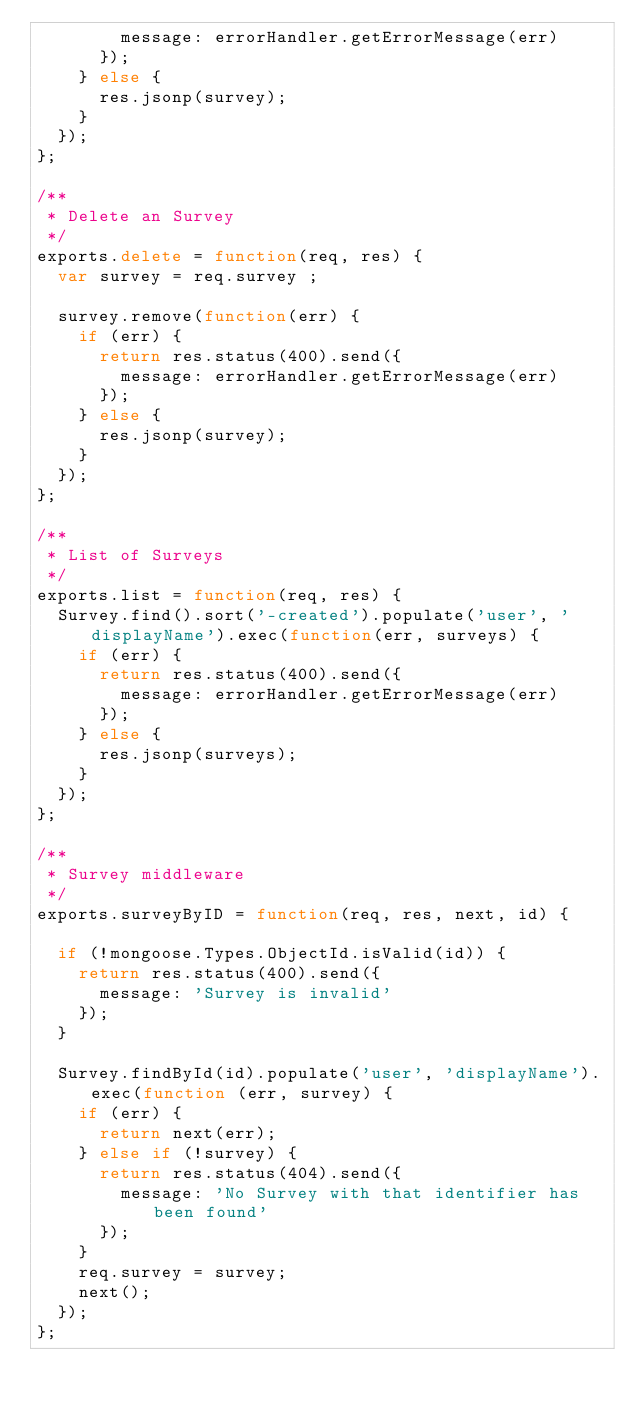Convert code to text. <code><loc_0><loc_0><loc_500><loc_500><_JavaScript_>        message: errorHandler.getErrorMessage(err)
      });
    } else {
      res.jsonp(survey);
    }
  });
};

/**
 * Delete an Survey
 */
exports.delete = function(req, res) {
  var survey = req.survey ;

  survey.remove(function(err) {
    if (err) {
      return res.status(400).send({
        message: errorHandler.getErrorMessage(err)
      });
    } else {
      res.jsonp(survey);
    }
  });
};

/**
 * List of Surveys
 */
exports.list = function(req, res) { 
  Survey.find().sort('-created').populate('user', 'displayName').exec(function(err, surveys) {
    if (err) {
      return res.status(400).send({
        message: errorHandler.getErrorMessage(err)
      });
    } else {
      res.jsonp(surveys);
    }
  });
};

/**
 * Survey middleware
 */
exports.surveyByID = function(req, res, next, id) {

  if (!mongoose.Types.ObjectId.isValid(id)) {
    return res.status(400).send({
      message: 'Survey is invalid'
    });
  }

  Survey.findById(id).populate('user', 'displayName').exec(function (err, survey) {
    if (err) {
      return next(err);
    } else if (!survey) {
      return res.status(404).send({
        message: 'No Survey with that identifier has been found'
      });
    }
    req.survey = survey;
    next();
  });
};
</code> 